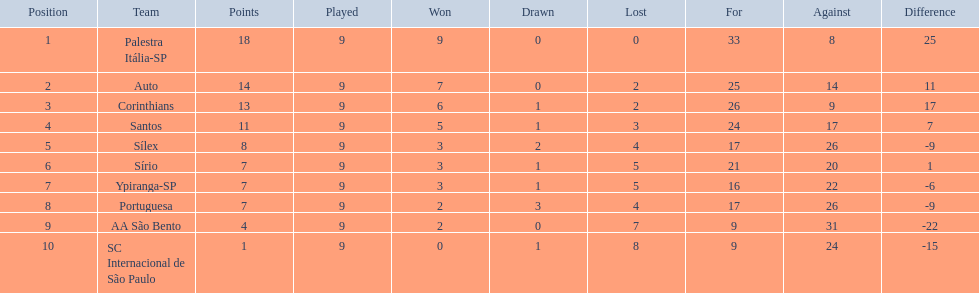How many game sessions did each crew have? 9, 9, 9, 9, 9, 9, 9, 9, 9, 9. Did any crew reach 13 points in their combined game sessions? 13. What is the name of that crew? Corinthians. 